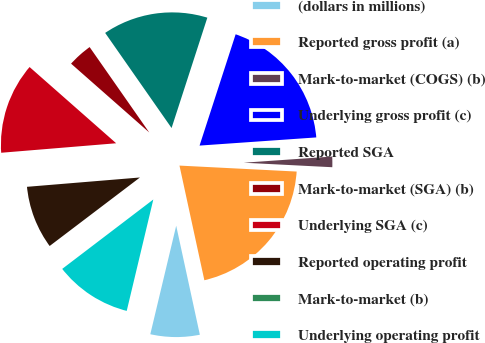Convert chart. <chart><loc_0><loc_0><loc_500><loc_500><pie_chart><fcel>(dollars in millions)<fcel>Reported gross profit (a)<fcel>Mark-to-market (COGS) (b)<fcel>Underlying gross profit (c)<fcel>Reported SGA<fcel>Mark-to-market (SGA) (b)<fcel>Underlying SGA (c)<fcel>Reported operating profit<fcel>Mark-to-market (b)<fcel>Underlying operating profit<nl><fcel>7.13%<fcel>20.79%<fcel>1.92%<fcel>18.9%<fcel>14.69%<fcel>3.81%<fcel>12.8%<fcel>9.02%<fcel>0.03%<fcel>10.91%<nl></chart> 